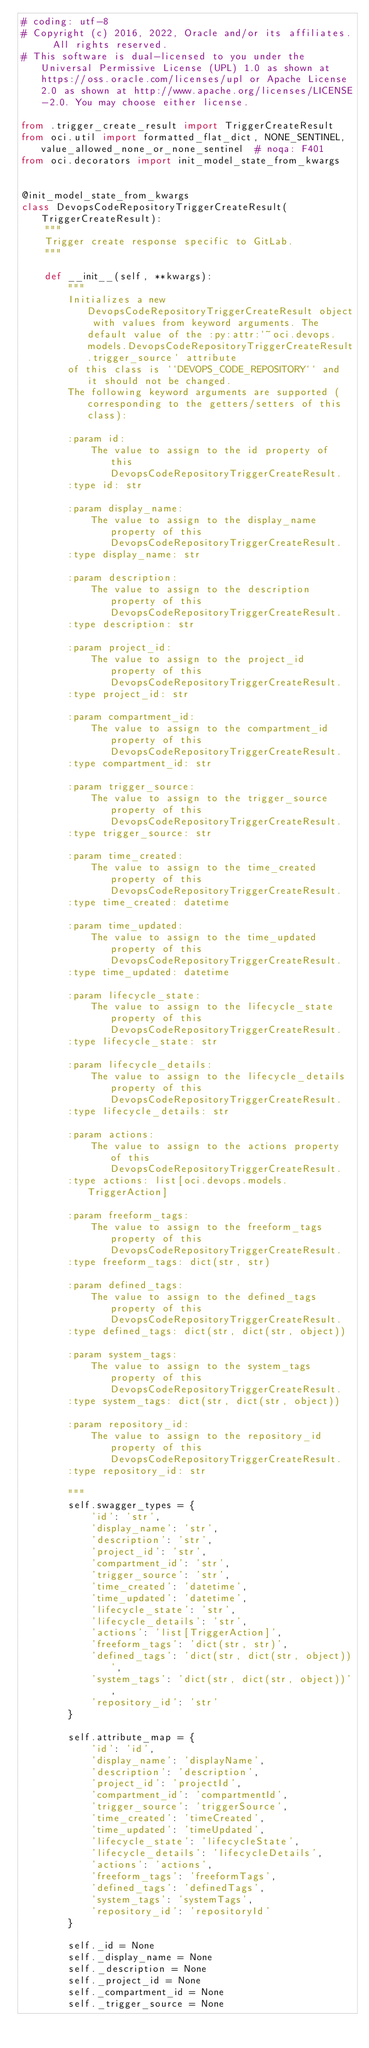<code> <loc_0><loc_0><loc_500><loc_500><_Python_># coding: utf-8
# Copyright (c) 2016, 2022, Oracle and/or its affiliates.  All rights reserved.
# This software is dual-licensed to you under the Universal Permissive License (UPL) 1.0 as shown at https://oss.oracle.com/licenses/upl or Apache License 2.0 as shown at http://www.apache.org/licenses/LICENSE-2.0. You may choose either license.

from .trigger_create_result import TriggerCreateResult
from oci.util import formatted_flat_dict, NONE_SENTINEL, value_allowed_none_or_none_sentinel  # noqa: F401
from oci.decorators import init_model_state_from_kwargs


@init_model_state_from_kwargs
class DevopsCodeRepositoryTriggerCreateResult(TriggerCreateResult):
    """
    Trigger create response specific to GitLab.
    """

    def __init__(self, **kwargs):
        """
        Initializes a new DevopsCodeRepositoryTriggerCreateResult object with values from keyword arguments. The default value of the :py:attr:`~oci.devops.models.DevopsCodeRepositoryTriggerCreateResult.trigger_source` attribute
        of this class is ``DEVOPS_CODE_REPOSITORY`` and it should not be changed.
        The following keyword arguments are supported (corresponding to the getters/setters of this class):

        :param id:
            The value to assign to the id property of this DevopsCodeRepositoryTriggerCreateResult.
        :type id: str

        :param display_name:
            The value to assign to the display_name property of this DevopsCodeRepositoryTriggerCreateResult.
        :type display_name: str

        :param description:
            The value to assign to the description property of this DevopsCodeRepositoryTriggerCreateResult.
        :type description: str

        :param project_id:
            The value to assign to the project_id property of this DevopsCodeRepositoryTriggerCreateResult.
        :type project_id: str

        :param compartment_id:
            The value to assign to the compartment_id property of this DevopsCodeRepositoryTriggerCreateResult.
        :type compartment_id: str

        :param trigger_source:
            The value to assign to the trigger_source property of this DevopsCodeRepositoryTriggerCreateResult.
        :type trigger_source: str

        :param time_created:
            The value to assign to the time_created property of this DevopsCodeRepositoryTriggerCreateResult.
        :type time_created: datetime

        :param time_updated:
            The value to assign to the time_updated property of this DevopsCodeRepositoryTriggerCreateResult.
        :type time_updated: datetime

        :param lifecycle_state:
            The value to assign to the lifecycle_state property of this DevopsCodeRepositoryTriggerCreateResult.
        :type lifecycle_state: str

        :param lifecycle_details:
            The value to assign to the lifecycle_details property of this DevopsCodeRepositoryTriggerCreateResult.
        :type lifecycle_details: str

        :param actions:
            The value to assign to the actions property of this DevopsCodeRepositoryTriggerCreateResult.
        :type actions: list[oci.devops.models.TriggerAction]

        :param freeform_tags:
            The value to assign to the freeform_tags property of this DevopsCodeRepositoryTriggerCreateResult.
        :type freeform_tags: dict(str, str)

        :param defined_tags:
            The value to assign to the defined_tags property of this DevopsCodeRepositoryTriggerCreateResult.
        :type defined_tags: dict(str, dict(str, object))

        :param system_tags:
            The value to assign to the system_tags property of this DevopsCodeRepositoryTriggerCreateResult.
        :type system_tags: dict(str, dict(str, object))

        :param repository_id:
            The value to assign to the repository_id property of this DevopsCodeRepositoryTriggerCreateResult.
        :type repository_id: str

        """
        self.swagger_types = {
            'id': 'str',
            'display_name': 'str',
            'description': 'str',
            'project_id': 'str',
            'compartment_id': 'str',
            'trigger_source': 'str',
            'time_created': 'datetime',
            'time_updated': 'datetime',
            'lifecycle_state': 'str',
            'lifecycle_details': 'str',
            'actions': 'list[TriggerAction]',
            'freeform_tags': 'dict(str, str)',
            'defined_tags': 'dict(str, dict(str, object))',
            'system_tags': 'dict(str, dict(str, object))',
            'repository_id': 'str'
        }

        self.attribute_map = {
            'id': 'id',
            'display_name': 'displayName',
            'description': 'description',
            'project_id': 'projectId',
            'compartment_id': 'compartmentId',
            'trigger_source': 'triggerSource',
            'time_created': 'timeCreated',
            'time_updated': 'timeUpdated',
            'lifecycle_state': 'lifecycleState',
            'lifecycle_details': 'lifecycleDetails',
            'actions': 'actions',
            'freeform_tags': 'freeformTags',
            'defined_tags': 'definedTags',
            'system_tags': 'systemTags',
            'repository_id': 'repositoryId'
        }

        self._id = None
        self._display_name = None
        self._description = None
        self._project_id = None
        self._compartment_id = None
        self._trigger_source = None</code> 